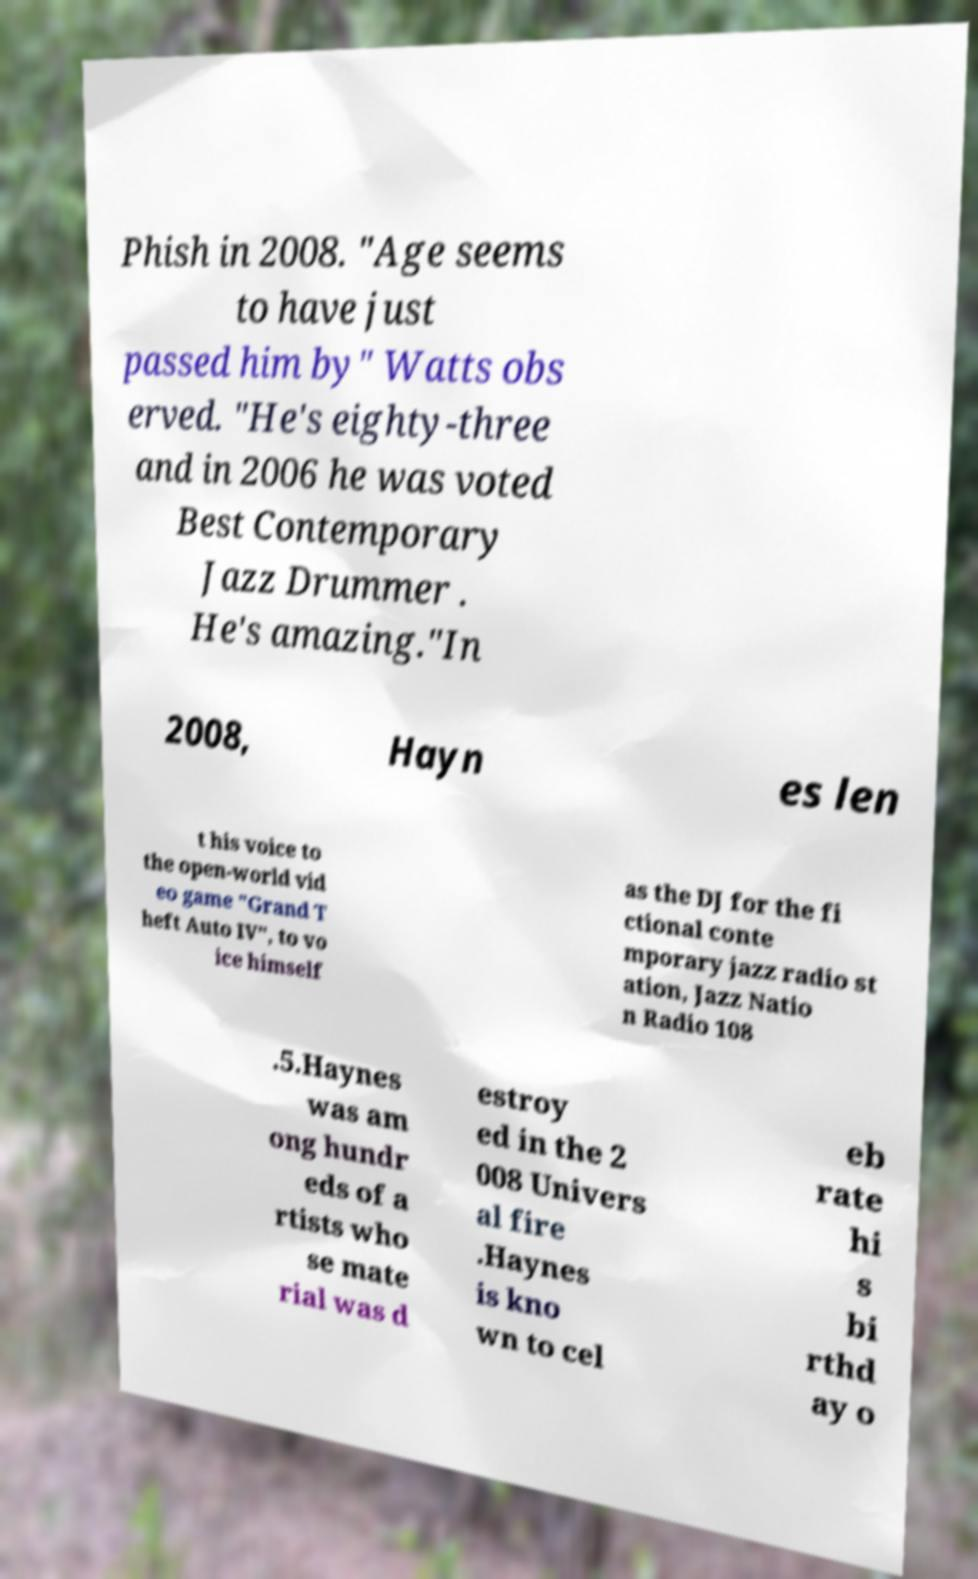Could you extract and type out the text from this image? Phish in 2008. "Age seems to have just passed him by" Watts obs erved. "He's eighty-three and in 2006 he was voted Best Contemporary Jazz Drummer . He's amazing."In 2008, Hayn es len t his voice to the open-world vid eo game "Grand T heft Auto IV", to vo ice himself as the DJ for the fi ctional conte mporary jazz radio st ation, Jazz Natio n Radio 108 .5.Haynes was am ong hundr eds of a rtists who se mate rial was d estroy ed in the 2 008 Univers al fire .Haynes is kno wn to cel eb rate hi s bi rthd ay o 